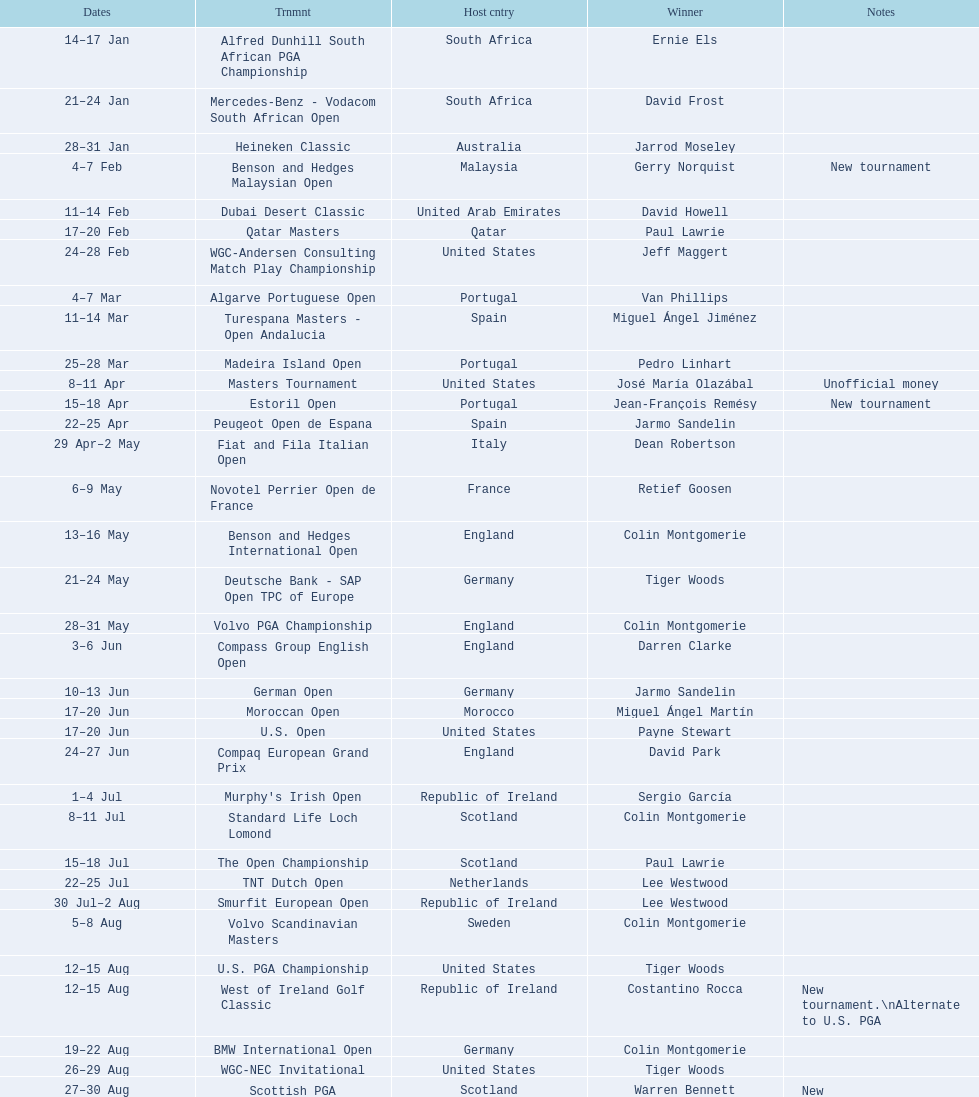Which tournament was later, volvo pga or algarve portuguese open? Volvo PGA. 